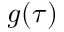<formula> <loc_0><loc_0><loc_500><loc_500>g ( \tau )</formula> 